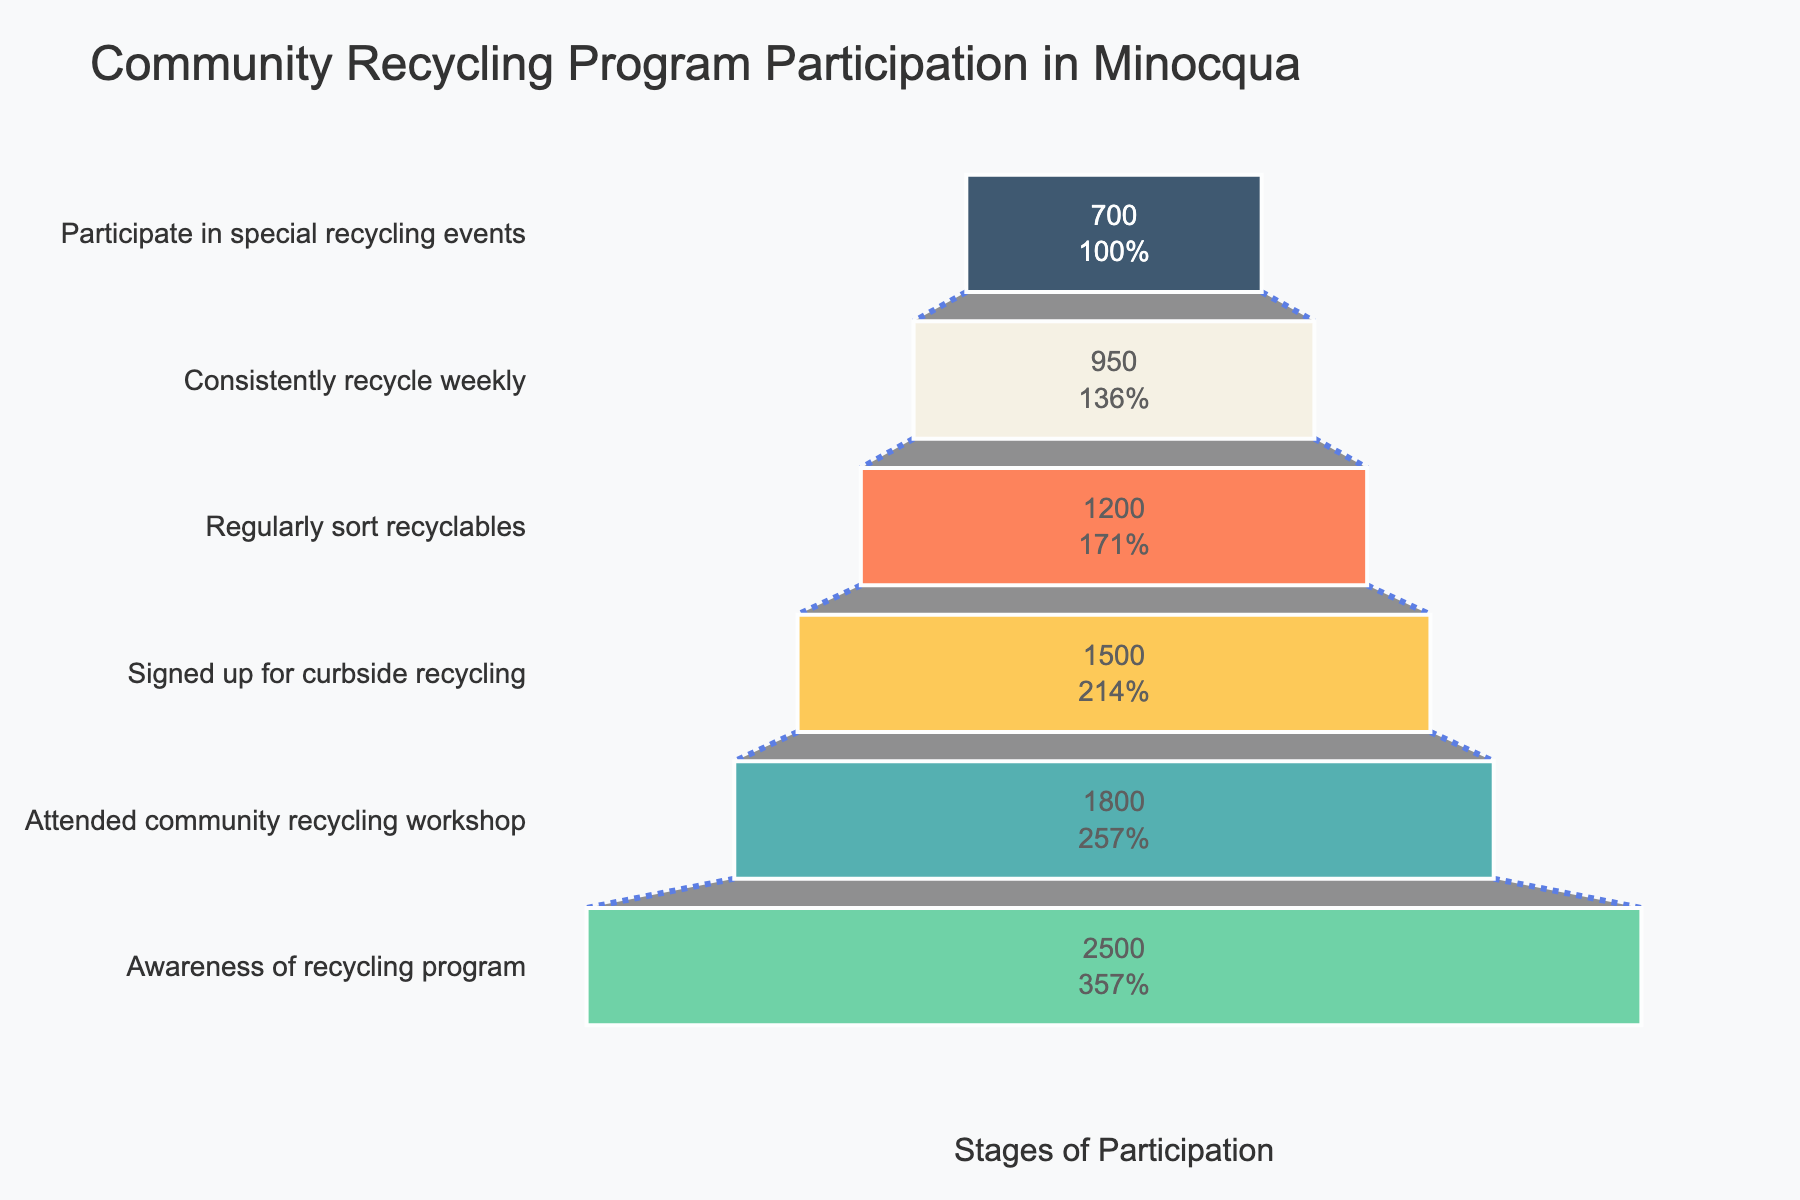What is the total number of participants who are aware of the recycling program? The number of participants at the "Awareness of recycling program" stage is directly shown as 2500 in the chart.
Answer: 2500 How many participants consistently recycle weekly? The number of participants who consistently recycle weekly is directly shown as 950 in the chart.
Answer: 950 What is the percentage of participants who signed up for curbside recycling out of those who attended the community recycling workshop? First, find the number of participants who attended the workshop (1800) and those who signed up for curbside recycling (1500). Then, calculate the percentage: (1500 / 1800) * 100.
Answer: 83.33% How many participants are lost between attending the community recycling workshop and signing up for curbside recycling? Subtract the number of participants who signed up for curbside recycling (1500) from those who attended the workshop (1800).
Answer: 300 Which stage has the biggest drop in participants from the previous stage? Compare the differences in the number of participants between each consecutive stage and identify the largest drop. The drops are: 2500 to 1800 (700), 1800 to 1500 (300), 1500 to 1200 (300), 1200 to 950 (250), 950 to 700 (250).
Answer: From awareness to attending workshop What is the ratio of participants who regularly sort recyclables to those who are aware of the recycling program? Divide the number of participants who regularly sort recyclables (1200) by the number of participants who are aware of the recycling program (2500).
Answer: 0.48 What percentage of participants who regularly sort recyclables also participate in special recycling events? First, find the number of participants who regularly sort recyclables (1200) and those who participate in special recycling events (700). Then, calculate the percentage: (700 / 1200) * 100.
Answer: 58.33% Which stage has the lowest number of participants? The chart shows the number of participants at each stage. Identify the stage with the smallest number: 700 at "Participate in special recycling events".
Answer: Participate in special recycling events What is the difference in the number of participants between those who consistently recycle weekly and those who regularly sort recyclables? Subtract the number of participants who consistently recycle weekly (950) from those who regularly sort recyclables (1200).
Answer: 250 How many more participants attended the community recycling workshop than those who participate in special recycling events? Subtract the number of participants who participate in special recycling events (700) from those who attended the community recycling workshop (1800).
Answer: 1100 